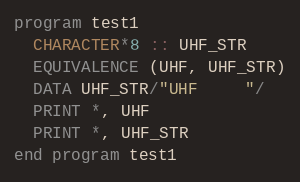<code> <loc_0><loc_0><loc_500><loc_500><_FORTRAN_>program test1
  CHARACTER*8 :: UHF_STR
  EQUIVALENCE (UHF, UHF_STR)
  DATA UHF_STR/"UHF     "/
  PRINT *, UHF
  PRINT *, UHF_STR
end program test1
</code> 